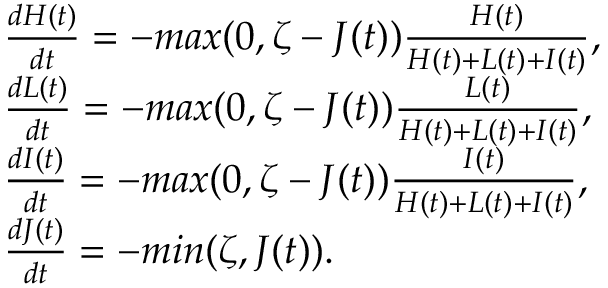<formula> <loc_0><loc_0><loc_500><loc_500>\begin{array} { l } { \frac { d H ( t ) } { d t } = - \max ( 0 , \zeta - J ( t ) ) \frac { H ( t ) } { H ( t ) + L ( t ) + I ( t ) } , } \\ { \frac { d L ( t ) } { d t } = - \max ( 0 , \zeta - J ( t ) ) \frac { L ( t ) } { H ( t ) + L ( t ) + I ( t ) } , } \\ { \frac { d I ( t ) } { d t } = - \max ( 0 , \zeta - J ( t ) ) \frac { I ( t ) } { H ( t ) + L ( t ) + I ( t ) } , } \\ { \frac { d J ( t ) } { d t } = - \min ( \zeta , J ( t ) ) . } \end{array}</formula> 